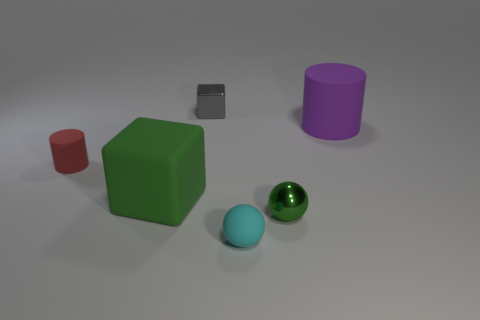Add 4 big matte cubes. How many objects exist? 10 Subtract all cylinders. How many objects are left? 4 Subtract 0 brown blocks. How many objects are left? 6 Subtract all tiny cyan metallic objects. Subtract all green things. How many objects are left? 4 Add 2 big blocks. How many big blocks are left? 3 Add 4 large green objects. How many large green objects exist? 5 